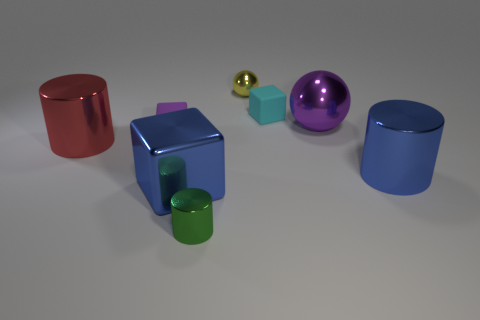The object that is the same color as the large shiny cube is what shape?
Make the answer very short. Cylinder. Are any yellow rubber objects visible?
Your answer should be compact. No. What number of shiny blocks have the same size as the blue cylinder?
Keep it short and to the point. 1. How many metallic objects are both on the right side of the yellow ball and left of the purple matte object?
Give a very brief answer. 0. There is a matte thing that is to the left of the green object; is it the same size as the red metal cylinder?
Keep it short and to the point. No. Is there a matte thing that has the same color as the large shiny sphere?
Provide a succinct answer. Yes. There is a green object that is the same material as the small yellow ball; what is its size?
Offer a very short reply. Small. Are there more large balls to the left of the cyan matte thing than small shiny things that are behind the red cylinder?
Provide a succinct answer. No. What number of other things are there of the same material as the big purple thing
Offer a very short reply. 5. Is the purple thing right of the tiny green thing made of the same material as the big red cylinder?
Offer a terse response. Yes. 